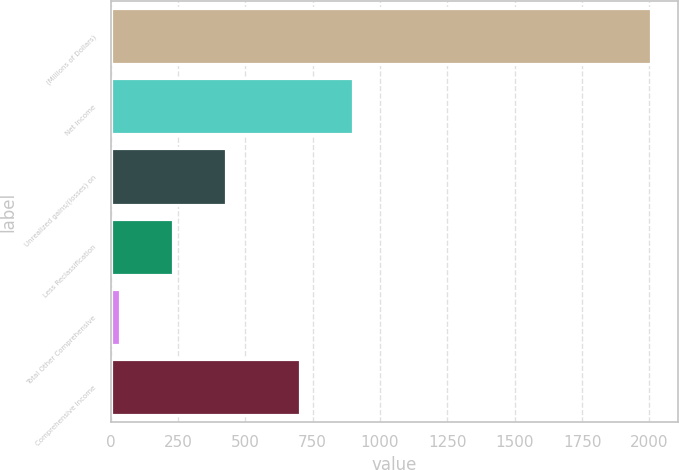Convert chart. <chart><loc_0><loc_0><loc_500><loc_500><bar_chart><fcel>(Millions of Dollars)<fcel>Net Income<fcel>Unrealized gains/(losses) on<fcel>Less Reclassification<fcel>Total Other Comprehensive<fcel>Comprehensive Income<nl><fcel>2006<fcel>901.3<fcel>427.6<fcel>230.3<fcel>33<fcel>704<nl></chart> 